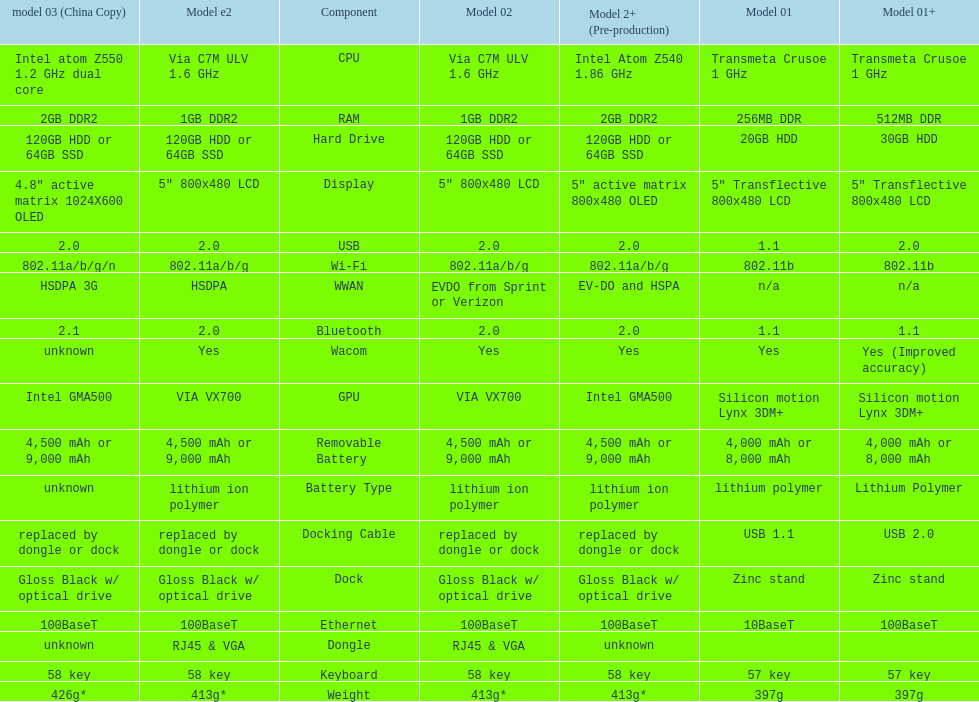What is the component before usb? Display. 